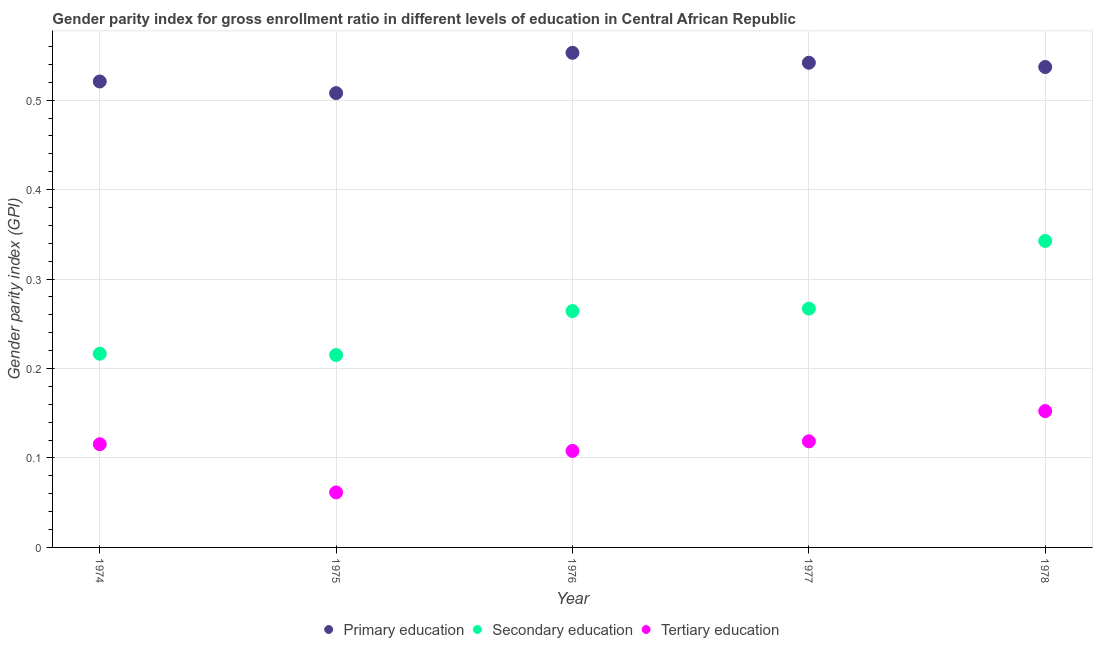What is the gender parity index in secondary education in 1976?
Make the answer very short. 0.26. Across all years, what is the maximum gender parity index in tertiary education?
Make the answer very short. 0.15. Across all years, what is the minimum gender parity index in tertiary education?
Keep it short and to the point. 0.06. In which year was the gender parity index in primary education maximum?
Offer a very short reply. 1976. In which year was the gender parity index in secondary education minimum?
Keep it short and to the point. 1975. What is the total gender parity index in tertiary education in the graph?
Offer a very short reply. 0.56. What is the difference between the gender parity index in tertiary education in 1976 and that in 1978?
Your response must be concise. -0.04. What is the difference between the gender parity index in secondary education in 1975 and the gender parity index in primary education in 1976?
Provide a short and direct response. -0.34. What is the average gender parity index in tertiary education per year?
Your answer should be very brief. 0.11. In the year 1976, what is the difference between the gender parity index in primary education and gender parity index in tertiary education?
Provide a short and direct response. 0.45. In how many years, is the gender parity index in secondary education greater than 0.22?
Your response must be concise. 3. What is the ratio of the gender parity index in tertiary education in 1976 to that in 1978?
Your response must be concise. 0.71. Is the gender parity index in tertiary education in 1974 less than that in 1977?
Your answer should be compact. Yes. Is the difference between the gender parity index in tertiary education in 1975 and 1978 greater than the difference between the gender parity index in secondary education in 1975 and 1978?
Provide a succinct answer. Yes. What is the difference between the highest and the second highest gender parity index in tertiary education?
Keep it short and to the point. 0.03. What is the difference between the highest and the lowest gender parity index in secondary education?
Your answer should be very brief. 0.13. Is the sum of the gender parity index in secondary education in 1974 and 1975 greater than the maximum gender parity index in primary education across all years?
Provide a succinct answer. No. Does the gender parity index in tertiary education monotonically increase over the years?
Offer a terse response. No. Is the gender parity index in primary education strictly less than the gender parity index in tertiary education over the years?
Ensure brevity in your answer.  No. How many years are there in the graph?
Offer a very short reply. 5. Are the values on the major ticks of Y-axis written in scientific E-notation?
Provide a short and direct response. No. Does the graph contain any zero values?
Your answer should be compact. No. Does the graph contain grids?
Keep it short and to the point. Yes. What is the title of the graph?
Your answer should be very brief. Gender parity index for gross enrollment ratio in different levels of education in Central African Republic. Does "Fuel" appear as one of the legend labels in the graph?
Offer a very short reply. No. What is the label or title of the X-axis?
Your answer should be very brief. Year. What is the label or title of the Y-axis?
Offer a very short reply. Gender parity index (GPI). What is the Gender parity index (GPI) of Primary education in 1974?
Offer a terse response. 0.52. What is the Gender parity index (GPI) in Secondary education in 1974?
Your answer should be compact. 0.22. What is the Gender parity index (GPI) in Tertiary education in 1974?
Give a very brief answer. 0.12. What is the Gender parity index (GPI) in Primary education in 1975?
Offer a very short reply. 0.51. What is the Gender parity index (GPI) in Secondary education in 1975?
Offer a terse response. 0.22. What is the Gender parity index (GPI) in Tertiary education in 1975?
Your answer should be compact. 0.06. What is the Gender parity index (GPI) in Primary education in 1976?
Offer a very short reply. 0.55. What is the Gender parity index (GPI) in Secondary education in 1976?
Offer a very short reply. 0.26. What is the Gender parity index (GPI) in Tertiary education in 1976?
Provide a short and direct response. 0.11. What is the Gender parity index (GPI) in Primary education in 1977?
Make the answer very short. 0.54. What is the Gender parity index (GPI) in Secondary education in 1977?
Provide a short and direct response. 0.27. What is the Gender parity index (GPI) of Tertiary education in 1977?
Offer a very short reply. 0.12. What is the Gender parity index (GPI) of Primary education in 1978?
Your answer should be compact. 0.54. What is the Gender parity index (GPI) in Secondary education in 1978?
Give a very brief answer. 0.34. What is the Gender parity index (GPI) of Tertiary education in 1978?
Your answer should be compact. 0.15. Across all years, what is the maximum Gender parity index (GPI) in Primary education?
Offer a terse response. 0.55. Across all years, what is the maximum Gender parity index (GPI) in Secondary education?
Ensure brevity in your answer.  0.34. Across all years, what is the maximum Gender parity index (GPI) in Tertiary education?
Your answer should be very brief. 0.15. Across all years, what is the minimum Gender parity index (GPI) in Primary education?
Your answer should be very brief. 0.51. Across all years, what is the minimum Gender parity index (GPI) of Secondary education?
Your answer should be compact. 0.22. Across all years, what is the minimum Gender parity index (GPI) of Tertiary education?
Provide a succinct answer. 0.06. What is the total Gender parity index (GPI) in Primary education in the graph?
Give a very brief answer. 2.66. What is the total Gender parity index (GPI) in Secondary education in the graph?
Your answer should be compact. 1.31. What is the total Gender parity index (GPI) of Tertiary education in the graph?
Provide a short and direct response. 0.56. What is the difference between the Gender parity index (GPI) in Primary education in 1974 and that in 1975?
Your answer should be very brief. 0.01. What is the difference between the Gender parity index (GPI) in Secondary education in 1974 and that in 1975?
Ensure brevity in your answer.  0. What is the difference between the Gender parity index (GPI) in Tertiary education in 1974 and that in 1975?
Ensure brevity in your answer.  0.05. What is the difference between the Gender parity index (GPI) in Primary education in 1974 and that in 1976?
Your answer should be compact. -0.03. What is the difference between the Gender parity index (GPI) of Secondary education in 1974 and that in 1976?
Your response must be concise. -0.05. What is the difference between the Gender parity index (GPI) in Tertiary education in 1974 and that in 1976?
Provide a short and direct response. 0.01. What is the difference between the Gender parity index (GPI) of Primary education in 1974 and that in 1977?
Make the answer very short. -0.02. What is the difference between the Gender parity index (GPI) of Secondary education in 1974 and that in 1977?
Offer a terse response. -0.05. What is the difference between the Gender parity index (GPI) of Tertiary education in 1974 and that in 1977?
Your response must be concise. -0. What is the difference between the Gender parity index (GPI) of Primary education in 1974 and that in 1978?
Make the answer very short. -0.02. What is the difference between the Gender parity index (GPI) of Secondary education in 1974 and that in 1978?
Your response must be concise. -0.13. What is the difference between the Gender parity index (GPI) in Tertiary education in 1974 and that in 1978?
Provide a short and direct response. -0.04. What is the difference between the Gender parity index (GPI) in Primary education in 1975 and that in 1976?
Offer a terse response. -0.04. What is the difference between the Gender parity index (GPI) of Secondary education in 1975 and that in 1976?
Your answer should be compact. -0.05. What is the difference between the Gender parity index (GPI) of Tertiary education in 1975 and that in 1976?
Give a very brief answer. -0.05. What is the difference between the Gender parity index (GPI) of Primary education in 1975 and that in 1977?
Your answer should be very brief. -0.03. What is the difference between the Gender parity index (GPI) in Secondary education in 1975 and that in 1977?
Ensure brevity in your answer.  -0.05. What is the difference between the Gender parity index (GPI) of Tertiary education in 1975 and that in 1977?
Offer a terse response. -0.06. What is the difference between the Gender parity index (GPI) in Primary education in 1975 and that in 1978?
Give a very brief answer. -0.03. What is the difference between the Gender parity index (GPI) in Secondary education in 1975 and that in 1978?
Offer a very short reply. -0.13. What is the difference between the Gender parity index (GPI) of Tertiary education in 1975 and that in 1978?
Ensure brevity in your answer.  -0.09. What is the difference between the Gender parity index (GPI) in Primary education in 1976 and that in 1977?
Provide a succinct answer. 0.01. What is the difference between the Gender parity index (GPI) of Secondary education in 1976 and that in 1977?
Offer a very short reply. -0. What is the difference between the Gender parity index (GPI) in Tertiary education in 1976 and that in 1977?
Make the answer very short. -0.01. What is the difference between the Gender parity index (GPI) in Primary education in 1976 and that in 1978?
Make the answer very short. 0.02. What is the difference between the Gender parity index (GPI) in Secondary education in 1976 and that in 1978?
Ensure brevity in your answer.  -0.08. What is the difference between the Gender parity index (GPI) in Tertiary education in 1976 and that in 1978?
Provide a short and direct response. -0.04. What is the difference between the Gender parity index (GPI) in Primary education in 1977 and that in 1978?
Offer a terse response. 0. What is the difference between the Gender parity index (GPI) in Secondary education in 1977 and that in 1978?
Provide a succinct answer. -0.08. What is the difference between the Gender parity index (GPI) in Tertiary education in 1977 and that in 1978?
Offer a very short reply. -0.03. What is the difference between the Gender parity index (GPI) in Primary education in 1974 and the Gender parity index (GPI) in Secondary education in 1975?
Provide a short and direct response. 0.31. What is the difference between the Gender parity index (GPI) in Primary education in 1974 and the Gender parity index (GPI) in Tertiary education in 1975?
Your answer should be very brief. 0.46. What is the difference between the Gender parity index (GPI) of Secondary education in 1974 and the Gender parity index (GPI) of Tertiary education in 1975?
Provide a short and direct response. 0.15. What is the difference between the Gender parity index (GPI) in Primary education in 1974 and the Gender parity index (GPI) in Secondary education in 1976?
Your response must be concise. 0.26. What is the difference between the Gender parity index (GPI) of Primary education in 1974 and the Gender parity index (GPI) of Tertiary education in 1976?
Provide a succinct answer. 0.41. What is the difference between the Gender parity index (GPI) of Secondary education in 1974 and the Gender parity index (GPI) of Tertiary education in 1976?
Give a very brief answer. 0.11. What is the difference between the Gender parity index (GPI) in Primary education in 1974 and the Gender parity index (GPI) in Secondary education in 1977?
Your answer should be very brief. 0.25. What is the difference between the Gender parity index (GPI) of Primary education in 1974 and the Gender parity index (GPI) of Tertiary education in 1977?
Provide a short and direct response. 0.4. What is the difference between the Gender parity index (GPI) of Secondary education in 1974 and the Gender parity index (GPI) of Tertiary education in 1977?
Offer a terse response. 0.1. What is the difference between the Gender parity index (GPI) in Primary education in 1974 and the Gender parity index (GPI) in Secondary education in 1978?
Offer a terse response. 0.18. What is the difference between the Gender parity index (GPI) of Primary education in 1974 and the Gender parity index (GPI) of Tertiary education in 1978?
Make the answer very short. 0.37. What is the difference between the Gender parity index (GPI) of Secondary education in 1974 and the Gender parity index (GPI) of Tertiary education in 1978?
Offer a terse response. 0.06. What is the difference between the Gender parity index (GPI) of Primary education in 1975 and the Gender parity index (GPI) of Secondary education in 1976?
Your answer should be compact. 0.24. What is the difference between the Gender parity index (GPI) of Primary education in 1975 and the Gender parity index (GPI) of Tertiary education in 1976?
Your response must be concise. 0.4. What is the difference between the Gender parity index (GPI) of Secondary education in 1975 and the Gender parity index (GPI) of Tertiary education in 1976?
Make the answer very short. 0.11. What is the difference between the Gender parity index (GPI) in Primary education in 1975 and the Gender parity index (GPI) in Secondary education in 1977?
Keep it short and to the point. 0.24. What is the difference between the Gender parity index (GPI) in Primary education in 1975 and the Gender parity index (GPI) in Tertiary education in 1977?
Your answer should be compact. 0.39. What is the difference between the Gender parity index (GPI) of Secondary education in 1975 and the Gender parity index (GPI) of Tertiary education in 1977?
Give a very brief answer. 0.1. What is the difference between the Gender parity index (GPI) of Primary education in 1975 and the Gender parity index (GPI) of Secondary education in 1978?
Provide a succinct answer. 0.17. What is the difference between the Gender parity index (GPI) of Primary education in 1975 and the Gender parity index (GPI) of Tertiary education in 1978?
Make the answer very short. 0.36. What is the difference between the Gender parity index (GPI) of Secondary education in 1975 and the Gender parity index (GPI) of Tertiary education in 1978?
Your answer should be very brief. 0.06. What is the difference between the Gender parity index (GPI) in Primary education in 1976 and the Gender parity index (GPI) in Secondary education in 1977?
Make the answer very short. 0.29. What is the difference between the Gender parity index (GPI) of Primary education in 1976 and the Gender parity index (GPI) of Tertiary education in 1977?
Your answer should be compact. 0.43. What is the difference between the Gender parity index (GPI) of Secondary education in 1976 and the Gender parity index (GPI) of Tertiary education in 1977?
Provide a short and direct response. 0.15. What is the difference between the Gender parity index (GPI) of Primary education in 1976 and the Gender parity index (GPI) of Secondary education in 1978?
Offer a very short reply. 0.21. What is the difference between the Gender parity index (GPI) of Primary education in 1976 and the Gender parity index (GPI) of Tertiary education in 1978?
Provide a short and direct response. 0.4. What is the difference between the Gender parity index (GPI) of Secondary education in 1976 and the Gender parity index (GPI) of Tertiary education in 1978?
Offer a terse response. 0.11. What is the difference between the Gender parity index (GPI) of Primary education in 1977 and the Gender parity index (GPI) of Secondary education in 1978?
Ensure brevity in your answer.  0.2. What is the difference between the Gender parity index (GPI) in Primary education in 1977 and the Gender parity index (GPI) in Tertiary education in 1978?
Your response must be concise. 0.39. What is the difference between the Gender parity index (GPI) of Secondary education in 1977 and the Gender parity index (GPI) of Tertiary education in 1978?
Offer a terse response. 0.11. What is the average Gender parity index (GPI) in Primary education per year?
Your response must be concise. 0.53. What is the average Gender parity index (GPI) of Secondary education per year?
Your answer should be very brief. 0.26. What is the average Gender parity index (GPI) in Tertiary education per year?
Provide a succinct answer. 0.11. In the year 1974, what is the difference between the Gender parity index (GPI) in Primary education and Gender parity index (GPI) in Secondary education?
Your answer should be very brief. 0.3. In the year 1974, what is the difference between the Gender parity index (GPI) of Primary education and Gender parity index (GPI) of Tertiary education?
Your answer should be very brief. 0.41. In the year 1974, what is the difference between the Gender parity index (GPI) of Secondary education and Gender parity index (GPI) of Tertiary education?
Your answer should be compact. 0.1. In the year 1975, what is the difference between the Gender parity index (GPI) of Primary education and Gender parity index (GPI) of Secondary education?
Make the answer very short. 0.29. In the year 1975, what is the difference between the Gender parity index (GPI) of Primary education and Gender parity index (GPI) of Tertiary education?
Offer a terse response. 0.45. In the year 1975, what is the difference between the Gender parity index (GPI) in Secondary education and Gender parity index (GPI) in Tertiary education?
Offer a very short reply. 0.15. In the year 1976, what is the difference between the Gender parity index (GPI) in Primary education and Gender parity index (GPI) in Secondary education?
Offer a terse response. 0.29. In the year 1976, what is the difference between the Gender parity index (GPI) of Primary education and Gender parity index (GPI) of Tertiary education?
Make the answer very short. 0.45. In the year 1976, what is the difference between the Gender parity index (GPI) of Secondary education and Gender parity index (GPI) of Tertiary education?
Your response must be concise. 0.16. In the year 1977, what is the difference between the Gender parity index (GPI) in Primary education and Gender parity index (GPI) in Secondary education?
Give a very brief answer. 0.27. In the year 1977, what is the difference between the Gender parity index (GPI) in Primary education and Gender parity index (GPI) in Tertiary education?
Your answer should be very brief. 0.42. In the year 1977, what is the difference between the Gender parity index (GPI) of Secondary education and Gender parity index (GPI) of Tertiary education?
Ensure brevity in your answer.  0.15. In the year 1978, what is the difference between the Gender parity index (GPI) in Primary education and Gender parity index (GPI) in Secondary education?
Your response must be concise. 0.19. In the year 1978, what is the difference between the Gender parity index (GPI) of Primary education and Gender parity index (GPI) of Tertiary education?
Offer a terse response. 0.38. In the year 1978, what is the difference between the Gender parity index (GPI) in Secondary education and Gender parity index (GPI) in Tertiary education?
Your answer should be very brief. 0.19. What is the ratio of the Gender parity index (GPI) of Primary education in 1974 to that in 1975?
Give a very brief answer. 1.03. What is the ratio of the Gender parity index (GPI) in Secondary education in 1974 to that in 1975?
Give a very brief answer. 1.01. What is the ratio of the Gender parity index (GPI) in Tertiary education in 1974 to that in 1975?
Offer a very short reply. 1.88. What is the ratio of the Gender parity index (GPI) in Primary education in 1974 to that in 1976?
Provide a short and direct response. 0.94. What is the ratio of the Gender parity index (GPI) of Secondary education in 1974 to that in 1976?
Your answer should be very brief. 0.82. What is the ratio of the Gender parity index (GPI) of Tertiary education in 1974 to that in 1976?
Your answer should be compact. 1.07. What is the ratio of the Gender parity index (GPI) in Primary education in 1974 to that in 1977?
Your response must be concise. 0.96. What is the ratio of the Gender parity index (GPI) of Secondary education in 1974 to that in 1977?
Your answer should be very brief. 0.81. What is the ratio of the Gender parity index (GPI) of Tertiary education in 1974 to that in 1977?
Your response must be concise. 0.97. What is the ratio of the Gender parity index (GPI) of Primary education in 1974 to that in 1978?
Your response must be concise. 0.97. What is the ratio of the Gender parity index (GPI) of Secondary education in 1974 to that in 1978?
Your answer should be very brief. 0.63. What is the ratio of the Gender parity index (GPI) of Tertiary education in 1974 to that in 1978?
Keep it short and to the point. 0.76. What is the ratio of the Gender parity index (GPI) in Primary education in 1975 to that in 1976?
Provide a short and direct response. 0.92. What is the ratio of the Gender parity index (GPI) of Secondary education in 1975 to that in 1976?
Offer a terse response. 0.81. What is the ratio of the Gender parity index (GPI) of Tertiary education in 1975 to that in 1976?
Keep it short and to the point. 0.57. What is the ratio of the Gender parity index (GPI) of Primary education in 1975 to that in 1977?
Provide a succinct answer. 0.94. What is the ratio of the Gender parity index (GPI) in Secondary education in 1975 to that in 1977?
Offer a terse response. 0.81. What is the ratio of the Gender parity index (GPI) in Tertiary education in 1975 to that in 1977?
Provide a succinct answer. 0.52. What is the ratio of the Gender parity index (GPI) of Primary education in 1975 to that in 1978?
Ensure brevity in your answer.  0.95. What is the ratio of the Gender parity index (GPI) of Secondary education in 1975 to that in 1978?
Ensure brevity in your answer.  0.63. What is the ratio of the Gender parity index (GPI) in Tertiary education in 1975 to that in 1978?
Give a very brief answer. 0.4. What is the ratio of the Gender parity index (GPI) in Primary education in 1976 to that in 1977?
Provide a succinct answer. 1.02. What is the ratio of the Gender parity index (GPI) in Tertiary education in 1976 to that in 1977?
Provide a succinct answer. 0.91. What is the ratio of the Gender parity index (GPI) in Primary education in 1976 to that in 1978?
Offer a very short reply. 1.03. What is the ratio of the Gender parity index (GPI) in Secondary education in 1976 to that in 1978?
Offer a terse response. 0.77. What is the ratio of the Gender parity index (GPI) of Tertiary education in 1976 to that in 1978?
Offer a terse response. 0.71. What is the ratio of the Gender parity index (GPI) of Primary education in 1977 to that in 1978?
Make the answer very short. 1.01. What is the ratio of the Gender parity index (GPI) in Secondary education in 1977 to that in 1978?
Ensure brevity in your answer.  0.78. What is the ratio of the Gender parity index (GPI) in Tertiary education in 1977 to that in 1978?
Make the answer very short. 0.78. What is the difference between the highest and the second highest Gender parity index (GPI) of Primary education?
Offer a terse response. 0.01. What is the difference between the highest and the second highest Gender parity index (GPI) in Secondary education?
Your response must be concise. 0.08. What is the difference between the highest and the second highest Gender parity index (GPI) of Tertiary education?
Provide a short and direct response. 0.03. What is the difference between the highest and the lowest Gender parity index (GPI) in Primary education?
Your answer should be very brief. 0.04. What is the difference between the highest and the lowest Gender parity index (GPI) of Secondary education?
Ensure brevity in your answer.  0.13. What is the difference between the highest and the lowest Gender parity index (GPI) of Tertiary education?
Offer a terse response. 0.09. 